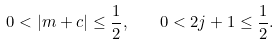Convert formula to latex. <formula><loc_0><loc_0><loc_500><loc_500>0 < | m + c | \leq \frac { 1 } { 2 } , \quad 0 < 2 j + 1 \leq \frac { 1 } { 2 } .</formula> 